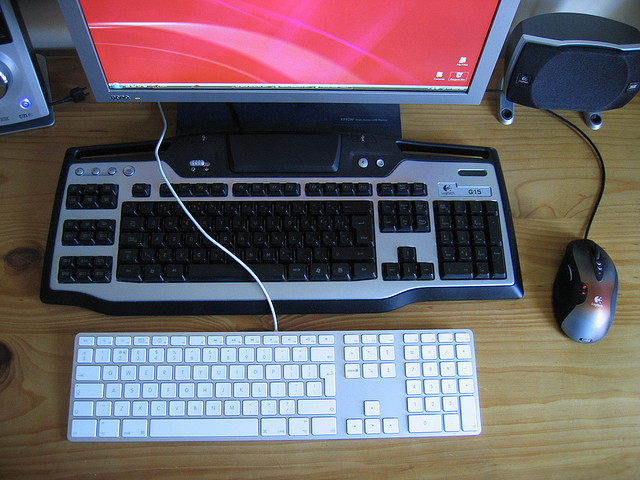Read and extract the text from this image. G15 